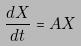Convert formula to latex. <formula><loc_0><loc_0><loc_500><loc_500>\frac { d X } { d t } = A X</formula> 